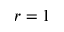<formula> <loc_0><loc_0><loc_500><loc_500>r = 1</formula> 